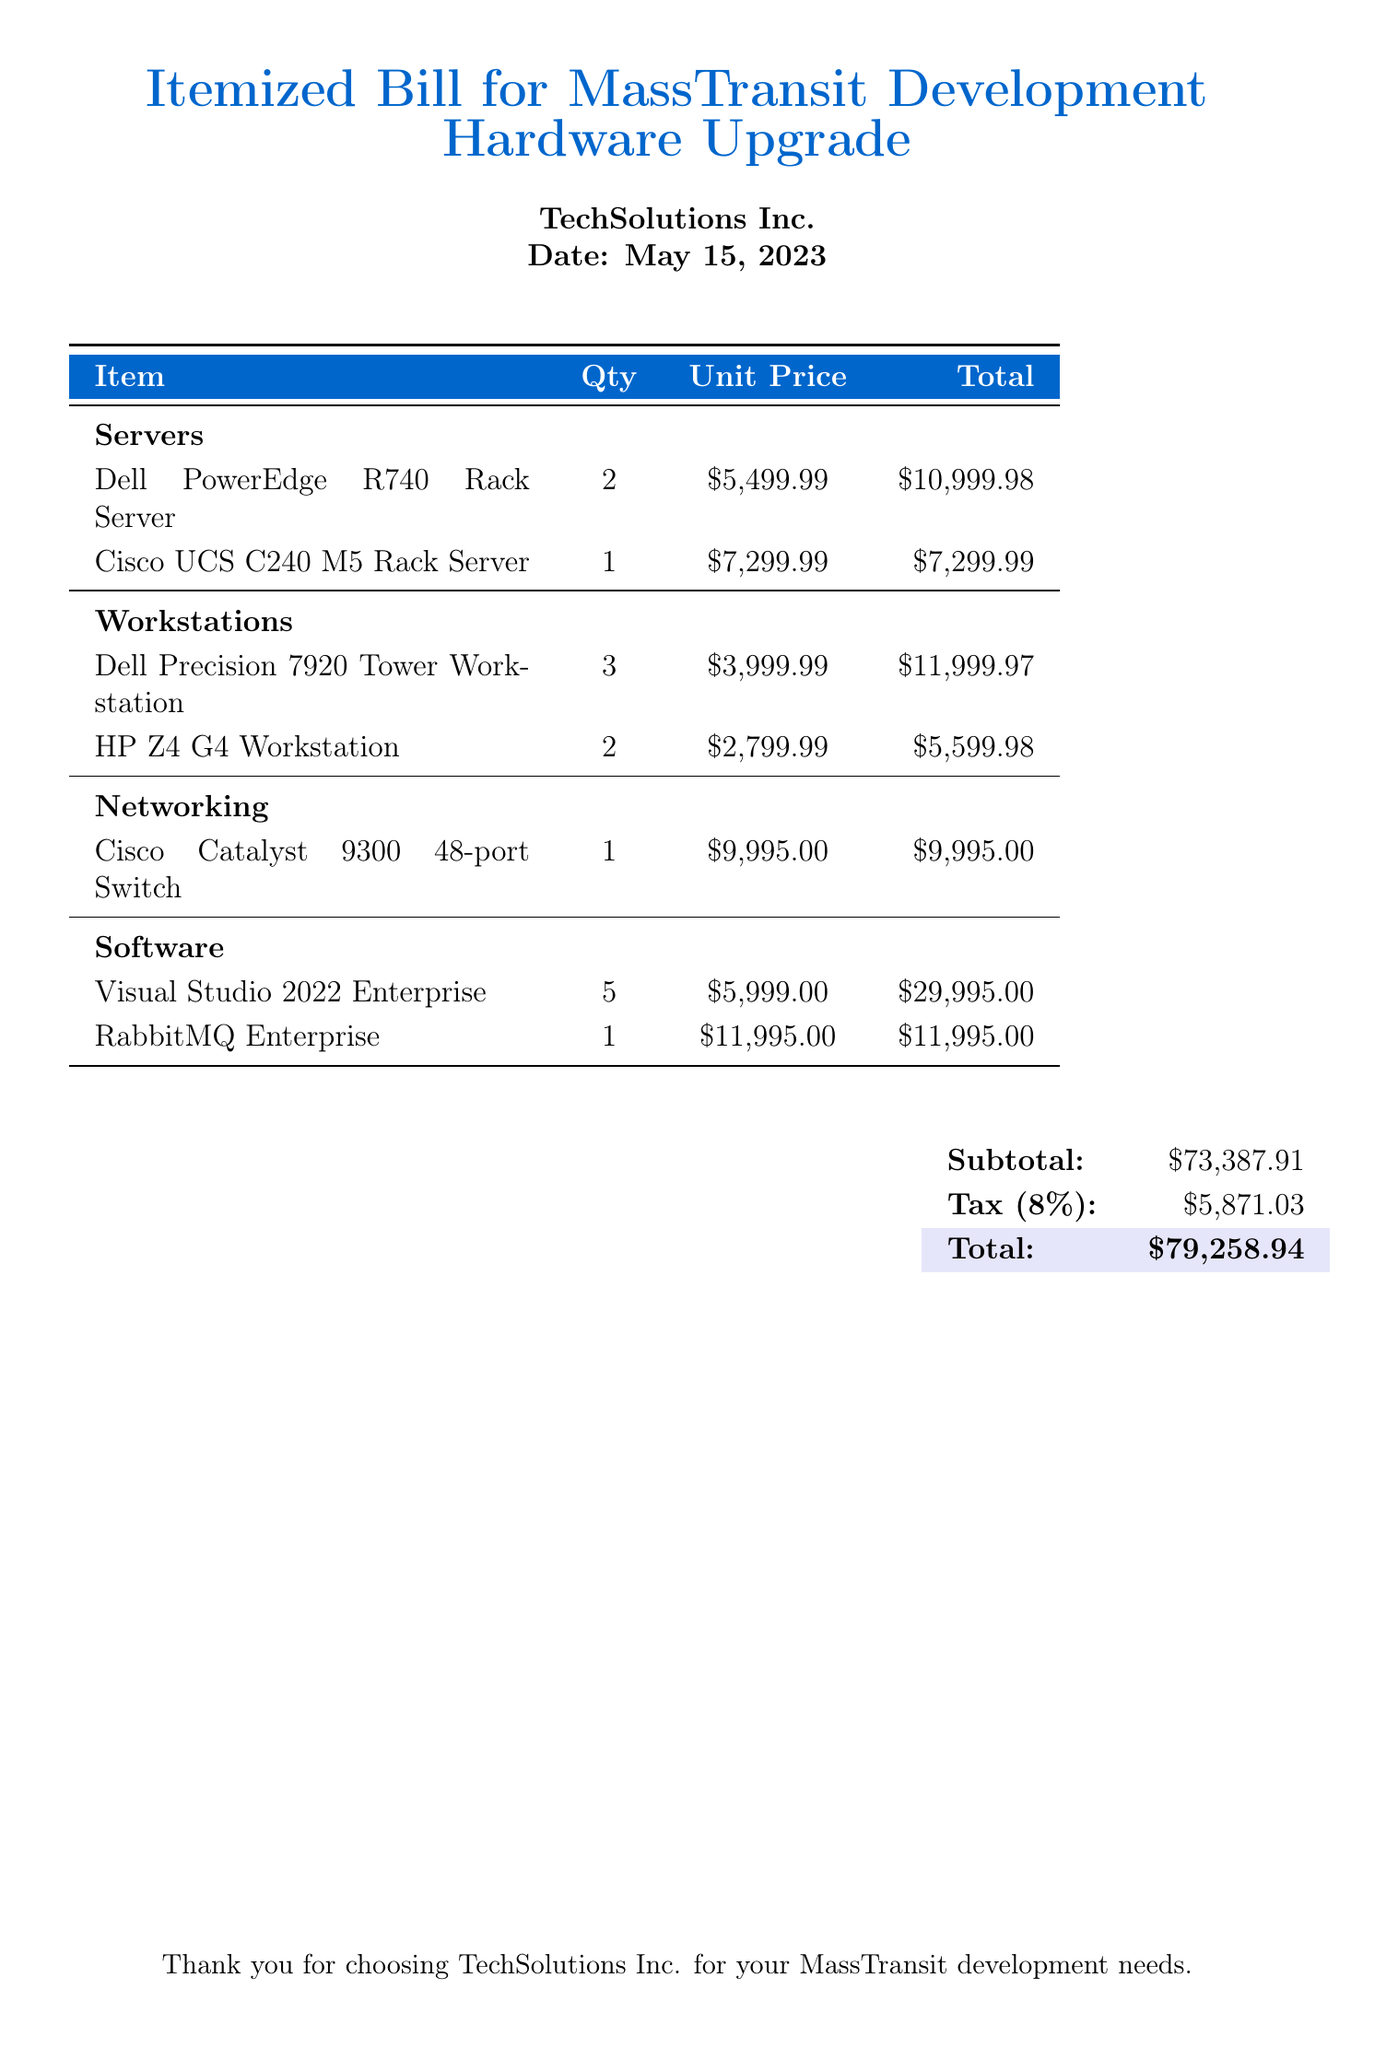how many Dell PowerEdge R740 Rack Servers are included? The document indicates that there are 2 units of Dell PowerEdge R740 Rack Servers listed.
Answer: 2 what is the total for the workstations? The total cost for the workstations is calculated by adding the totals of the Dell Precision 7920 Tower Workstations and HP Z4 G4 Workstations, which is $11,999.97 + $5,599.98.
Answer: $17,599.95 what is the subtotal of the bill? The subtotal is the sum of all the individual item costs before tax, stated clearly in the document.
Answer: $73,387.91 which networking equipment is listed? The document specifies the Cisco Catalyst 9300 48-port Switch as the networking equipment included in the bill.
Answer: Cisco Catalyst 9300 48-port Switch how much does each unit of Visual Studio 2022 Enterprise cost? The document lists the unit price of Visual Studio 2022 Enterprise, which is provided for each license of the software.
Answer: $5,999.00 what is the tax percentage applied to the subtotal? The tax percentage is explicitly stated in the document as part of the billing details.
Answer: 8% what is the total cost after tax? The total cost is computed by adding the subtotal and the tax, which is displayed at the end of the document.
Answer: $79,258.94 